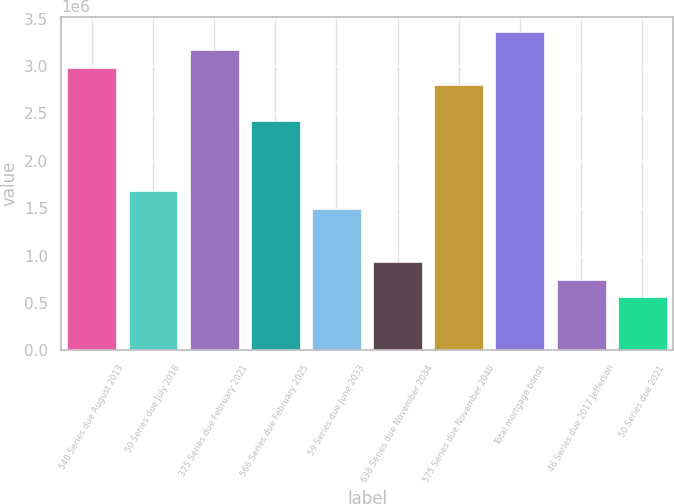Convert chart to OTSL. <chart><loc_0><loc_0><loc_500><loc_500><bar_chart><fcel>540 Series due August 2013<fcel>50 Series due July 2018<fcel>375 Series due February 2021<fcel>566 Series due February 2025<fcel>59 Series due June 2033<fcel>638 Series due November 2034<fcel>575 Series due November 2040<fcel>Total mortgage bonds<fcel>46 Series due 2017 Jefferson<fcel>50 Series due 2021<nl><fcel>2.98225e+06<fcel>1.67752e+06<fcel>3.16864e+06<fcel>2.42308e+06<fcel>1.49113e+06<fcel>931956<fcel>2.79586e+06<fcel>3.35504e+06<fcel>745566<fcel>559175<nl></chart> 